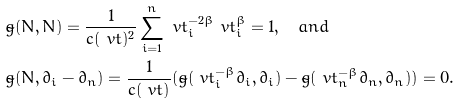<formula> <loc_0><loc_0><loc_500><loc_500>& \tilde { g } ( N , N ) = \frac { 1 } { c ( \ v t ) ^ { 2 } } \sum _ { i = 1 } ^ { n } \ v t _ { i } ^ { - 2 \beta } \ v t _ { i } ^ { \beta } = 1 , \quad a n d \\ & \tilde { g } ( N , \partial _ { i } - \partial _ { n } ) = \frac { 1 } { c ( \ v t ) } ( \tilde { g } ( \ v t _ { i } ^ { - \beta } \partial _ { i } , \partial _ { i } ) - \tilde { g } ( \ v t _ { n } ^ { - \beta } \partial _ { n } , \partial _ { n } ) ) = 0 .</formula> 